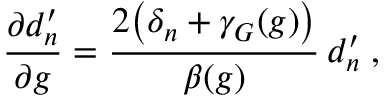Convert formula to latex. <formula><loc_0><loc_0><loc_500><loc_500>\frac { \partial d _ { n } ^ { \prime } } { \partial g } = \frac { 2 \left ( \delta _ { n } + \gamma _ { G } ( g ) \right ) } { \beta ( g ) } \, d _ { n } ^ { \prime } \, ,</formula> 